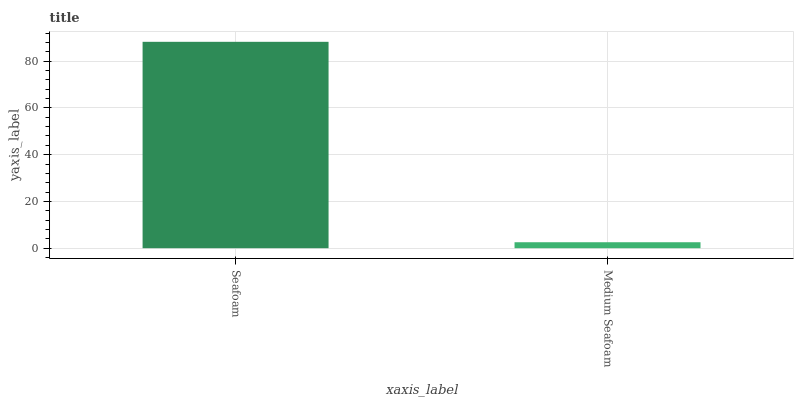Is Medium Seafoam the minimum?
Answer yes or no. Yes. Is Seafoam the maximum?
Answer yes or no. Yes. Is Medium Seafoam the maximum?
Answer yes or no. No. Is Seafoam greater than Medium Seafoam?
Answer yes or no. Yes. Is Medium Seafoam less than Seafoam?
Answer yes or no. Yes. Is Medium Seafoam greater than Seafoam?
Answer yes or no. No. Is Seafoam less than Medium Seafoam?
Answer yes or no. No. Is Seafoam the high median?
Answer yes or no. Yes. Is Medium Seafoam the low median?
Answer yes or no. Yes. Is Medium Seafoam the high median?
Answer yes or no. No. Is Seafoam the low median?
Answer yes or no. No. 